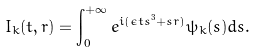<formula> <loc_0><loc_0><loc_500><loc_500>I _ { k } ( t , r ) = \int _ { 0 } ^ { + \infty } e ^ { i ( \epsilon t s ^ { 3 } + s r ) } \psi _ { k } ( s ) d s .</formula> 